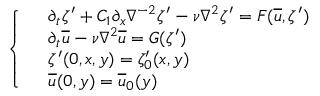Convert formula to latex. <formula><loc_0><loc_0><loc_500><loc_500>\left \{ \begin{array} { l l } & { \partial _ { t } \zeta ^ { \prime } + C _ { 1 } \partial _ { x } \nabla ^ { - 2 } \zeta ^ { \prime } - \nu \nabla ^ { 2 } \zeta ^ { \prime } = F ( \overline { u } , \zeta ^ { \prime } ) } \\ & { \partial _ { t } \overline { u } - \nu \nabla ^ { 2 } \overline { u } = G ( \zeta ^ { \prime } ) } \\ & { \zeta ^ { \prime } ( 0 , x , y ) = \zeta _ { 0 } ^ { \prime } ( x , y ) } \\ & { \overline { u } ( 0 , y ) = \overline { u } _ { 0 } ( y ) } \end{array}</formula> 